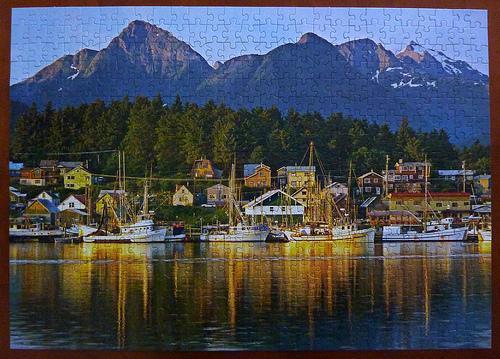How many boats are there?
Give a very brief answer. 4. 